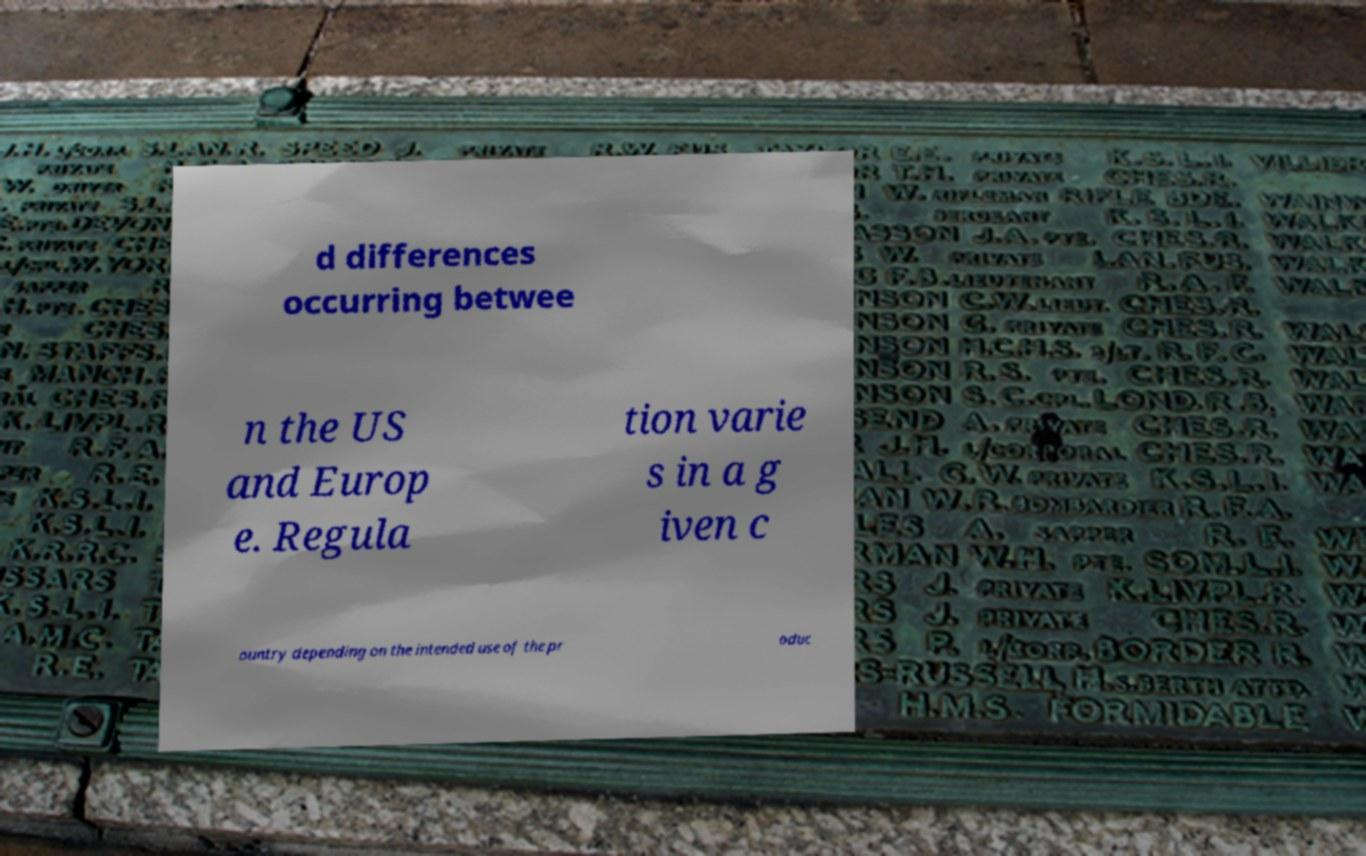There's text embedded in this image that I need extracted. Can you transcribe it verbatim? d differences occurring betwee n the US and Europ e. Regula tion varie s in a g iven c ountry depending on the intended use of the pr oduc 